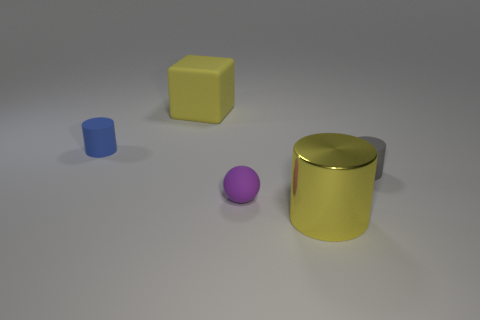Is there anything else that has the same material as the large cylinder?
Make the answer very short. No. How many rubber things are right of the blue object and left of the small rubber sphere?
Give a very brief answer. 1. What is the color of the large metallic object that is the same shape as the gray matte object?
Make the answer very short. Yellow. Is the number of brown rubber things less than the number of large rubber objects?
Provide a short and direct response. Yes. Do the yellow metal cylinder and the cylinder behind the gray cylinder have the same size?
Your answer should be compact. No. There is a tiny sphere that is in front of the small object that is on the left side of the big yellow matte block; what is its color?
Offer a very short reply. Purple. How many objects are either things behind the yellow metal cylinder or things in front of the small blue rubber thing?
Your response must be concise. 5. Do the matte block and the gray rubber cylinder have the same size?
Offer a terse response. No. Are there any other things that are the same size as the yellow metallic thing?
Provide a succinct answer. Yes. There is a small rubber thing to the left of the large rubber object; does it have the same shape as the small gray thing that is on the right side of the blue object?
Offer a very short reply. Yes. 